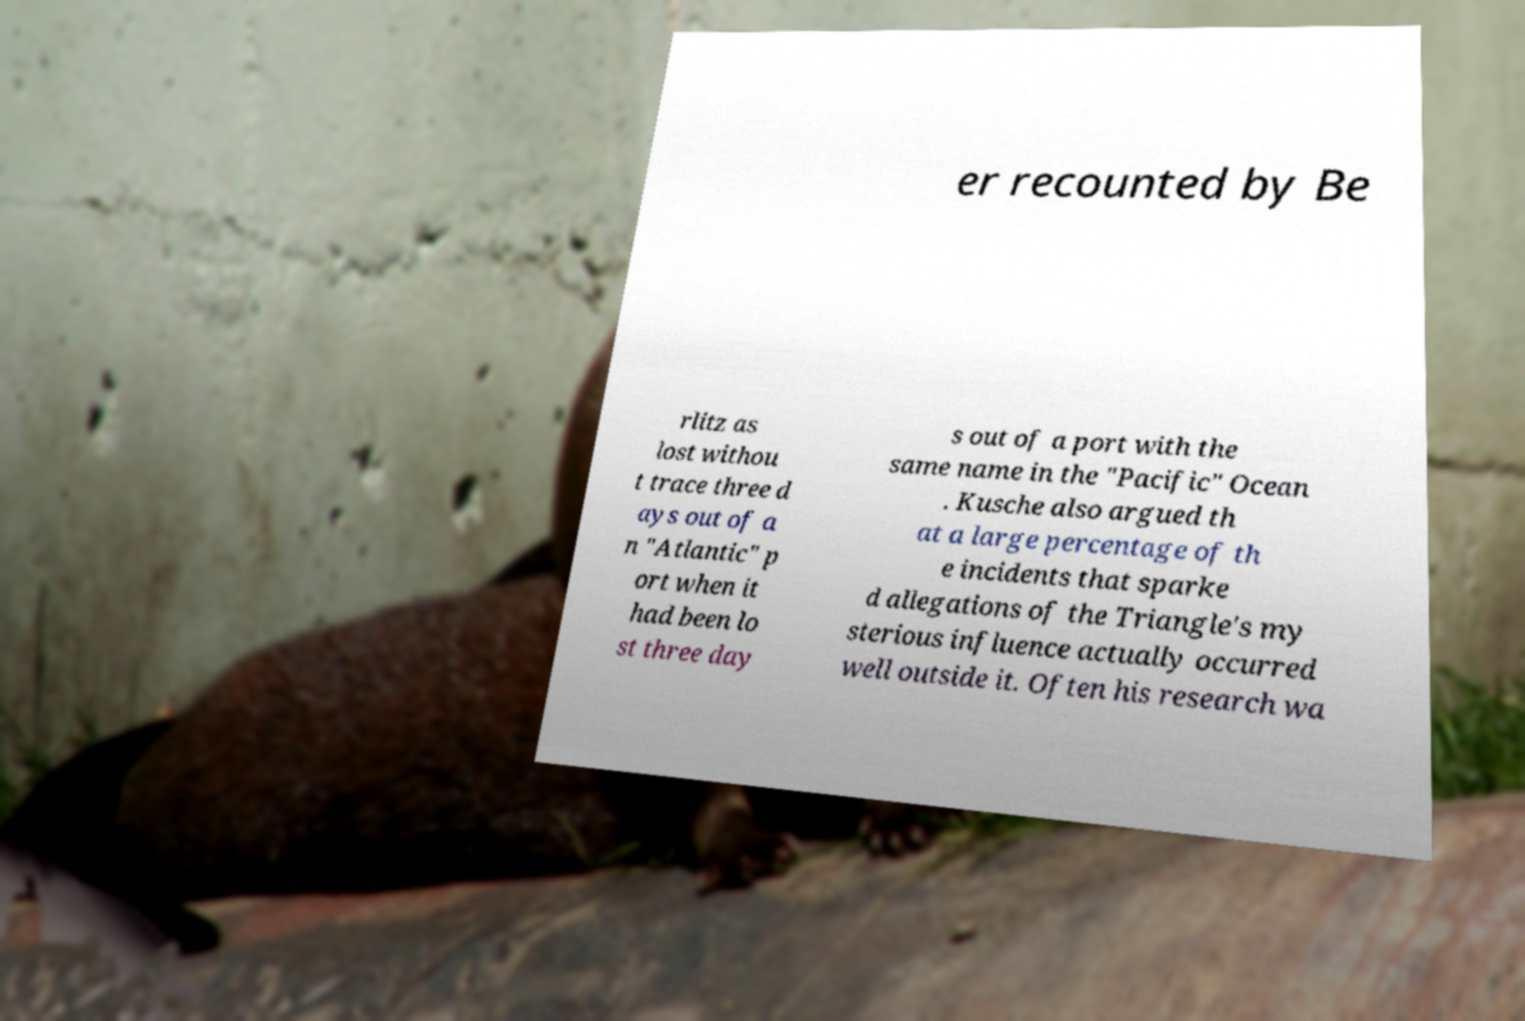For documentation purposes, I need the text within this image transcribed. Could you provide that? er recounted by Be rlitz as lost withou t trace three d ays out of a n "Atlantic" p ort when it had been lo st three day s out of a port with the same name in the "Pacific" Ocean . Kusche also argued th at a large percentage of th e incidents that sparke d allegations of the Triangle's my sterious influence actually occurred well outside it. Often his research wa 